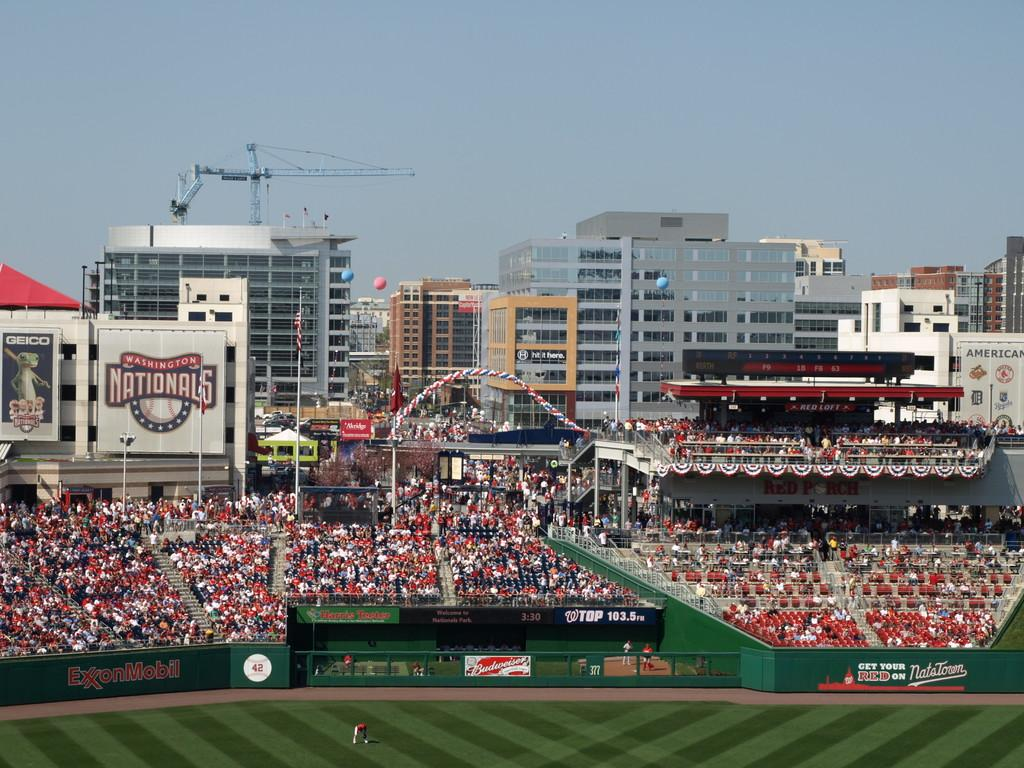<image>
Share a concise interpretation of the image provided. Washington Nationals baseball stadium with lots of fans watching a baseball game. 